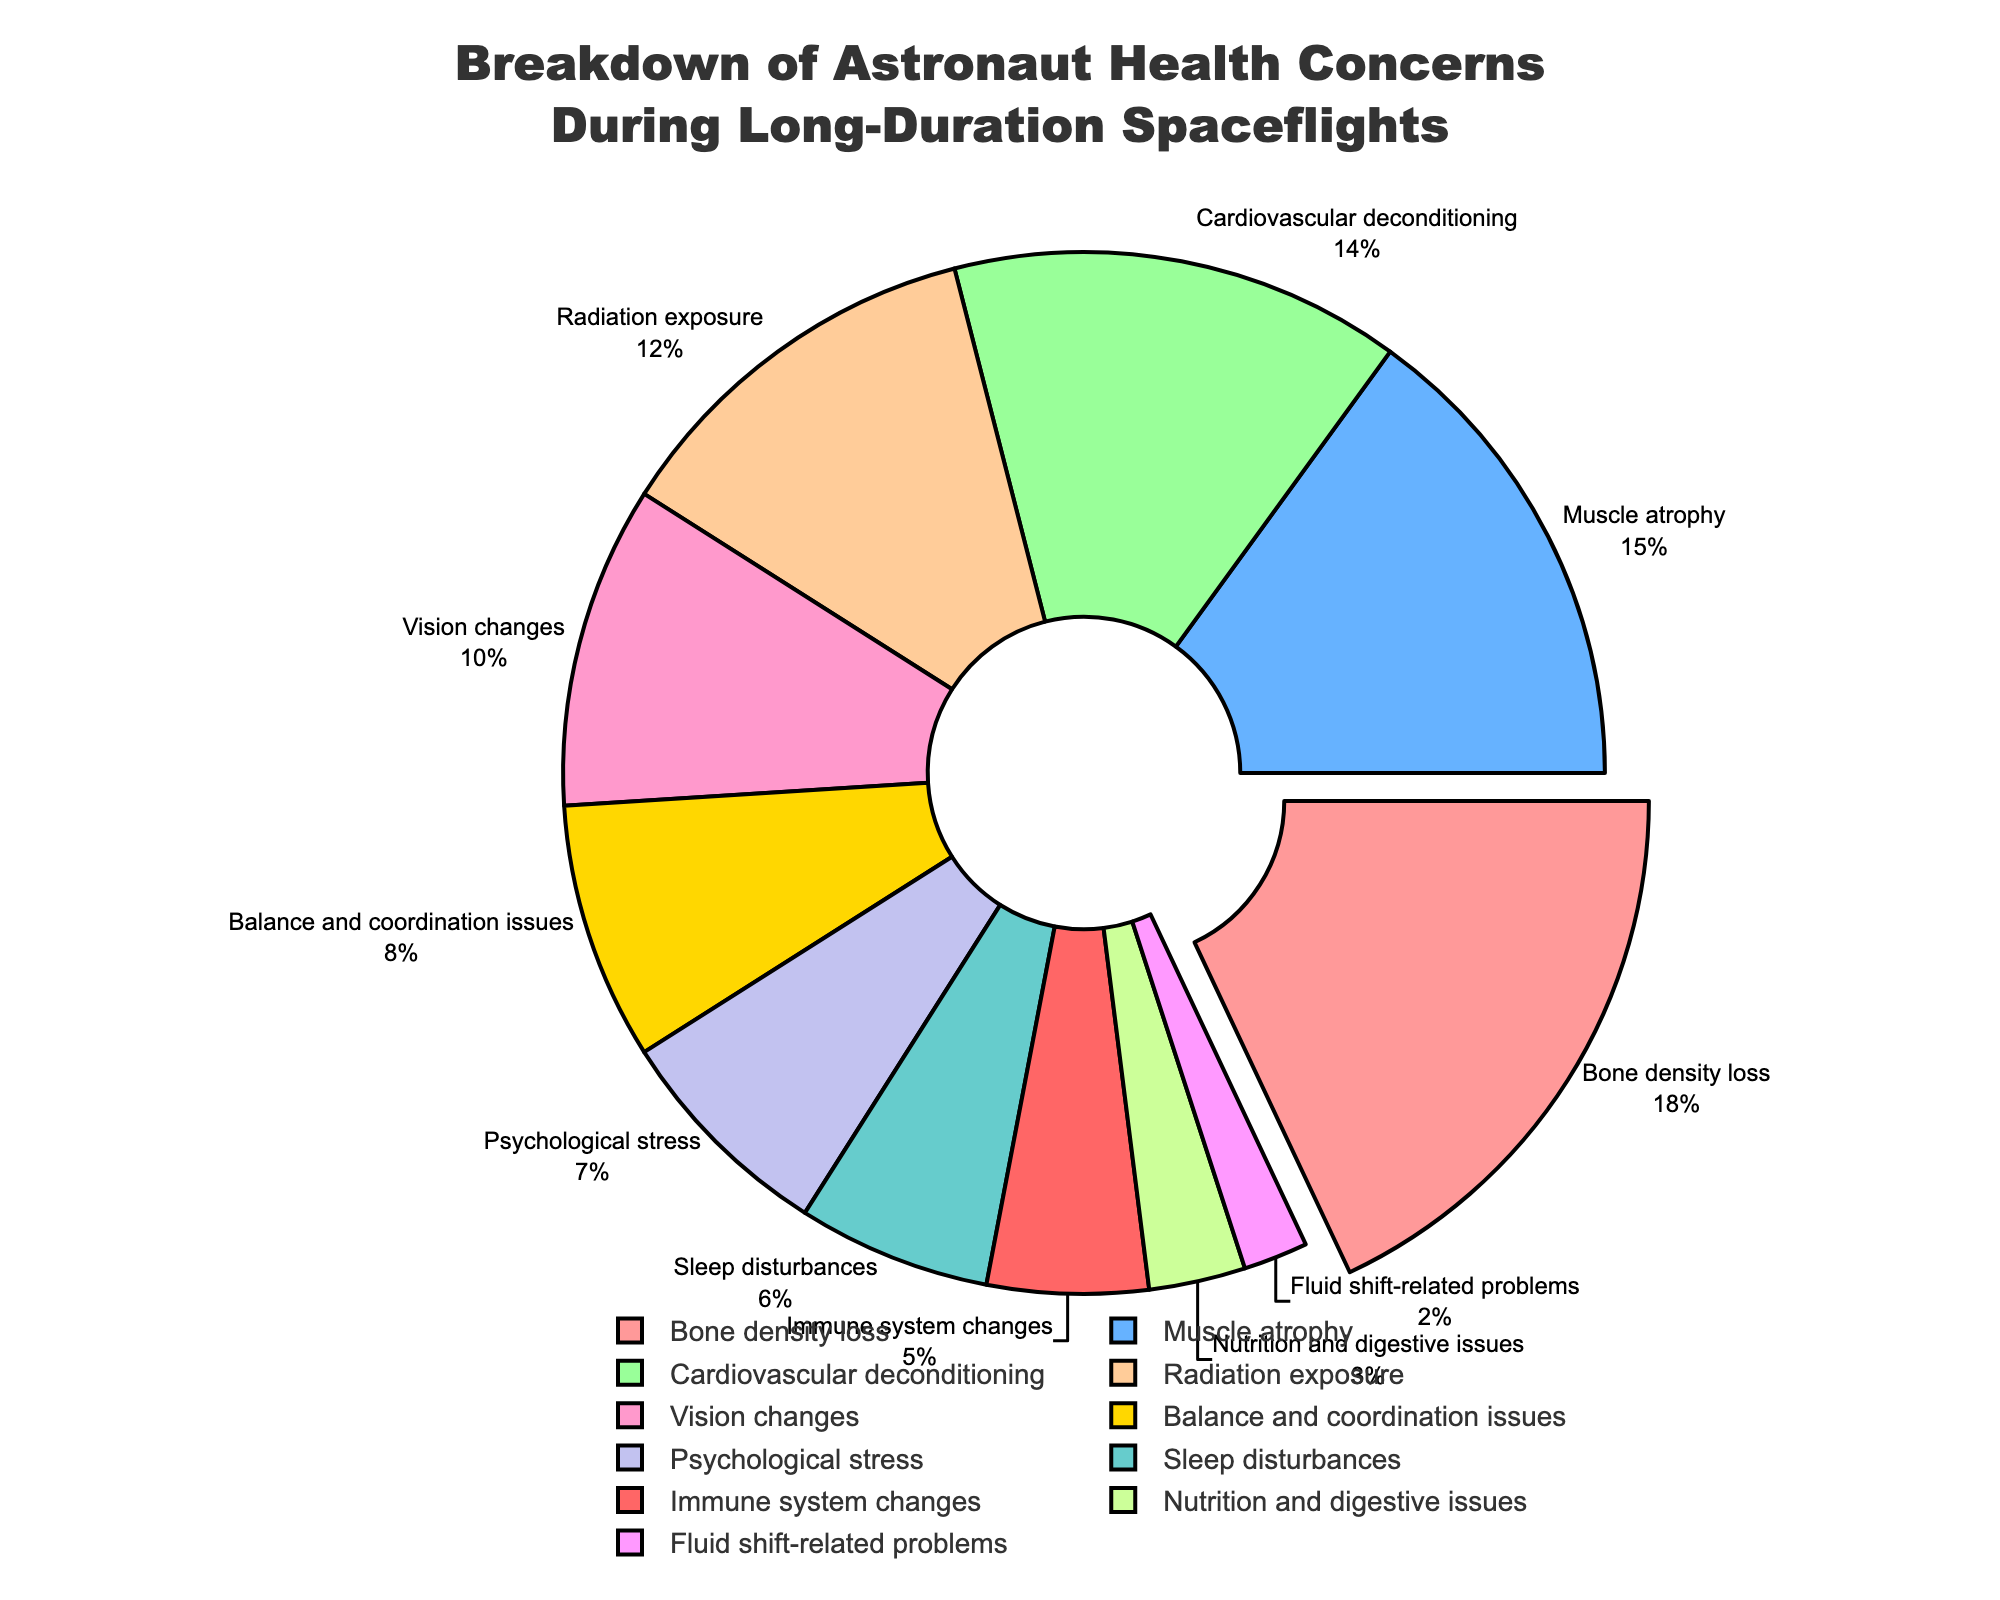What category has the highest percentage of health concerns? The pie chart shows that "Bone density loss" has the largest section pulled out from the pie, indicating it has the highest percentage.
Answer: Bone density loss Which two categories combined have a percentage of 30%? To find two categories that sum up to 30%, we look for pairs in the pie chart whose percentages together equal 30. "Muscle atrophy" (15%) and "Cardiovascular deconditioning" (14%) combined with "Fluid shift-related problems" (1%) give 30%.
Answer: Muscle atrophy and Cardiovascular deconditioning How much more does the highest category contribute compared to the second highest? The highest category is "Bone density loss" at 18%, and the second highest is "Muscle atrophy" at 15%. The difference is 18% - 15% = 3%.
Answer: 3% Which health concern category has the smallest percentage, and what is it? The smallest percentage shown is for "Fluid shift-related problems", marked at 2%.
Answer: Fluid shift-related problems What are the total combined percentages of the concerns involving the cardiovascular system? The only category directly related to the cardiovascular system is "Cardiovascular deconditioning" at 14%.
Answer: 14% Which category contributes more to health concerns, "Psychological stress" or "Sleep disturbances"? According to the pie chart, "Psychological stress" contributes 7%, while "Sleep disturbances" contributes 6%. Comparing the two, "Psychological stress" is higher.
Answer: Psychological stress What is the combined percentage of "Radiation exposure" and "Vision changes"? "Radiation exposure" represents 12%, and "Vision changes" represents 10%. Adding these, 12% + 10% = 22%.
Answer: 22% How does the percentage of "Nutrition and digestive issues" compare to "Immune system changes"? "Nutrition and digestive issues" are at 3%, whereas "Immune system changes" are at 5%. Thus, "Immune system changes" are greater by 2%.
Answer: "Immune system changes" are greater by 2% Which categories have percentages less than 10%? The categories with less than 10% are: "Balance and coordination issues" (8%), "Psychological stress" (7%), "Sleep disturbances" (6%), "Immune system changes" (5%), "Nutrition and digestive issues" (3%), and "Fluid shift-related problems" (2%).
Answer: Balance and coordination issues, Psychological stress, Sleep disturbances, Immune system changes, Nutrition and digestive issues, Fluid shift-related problems 